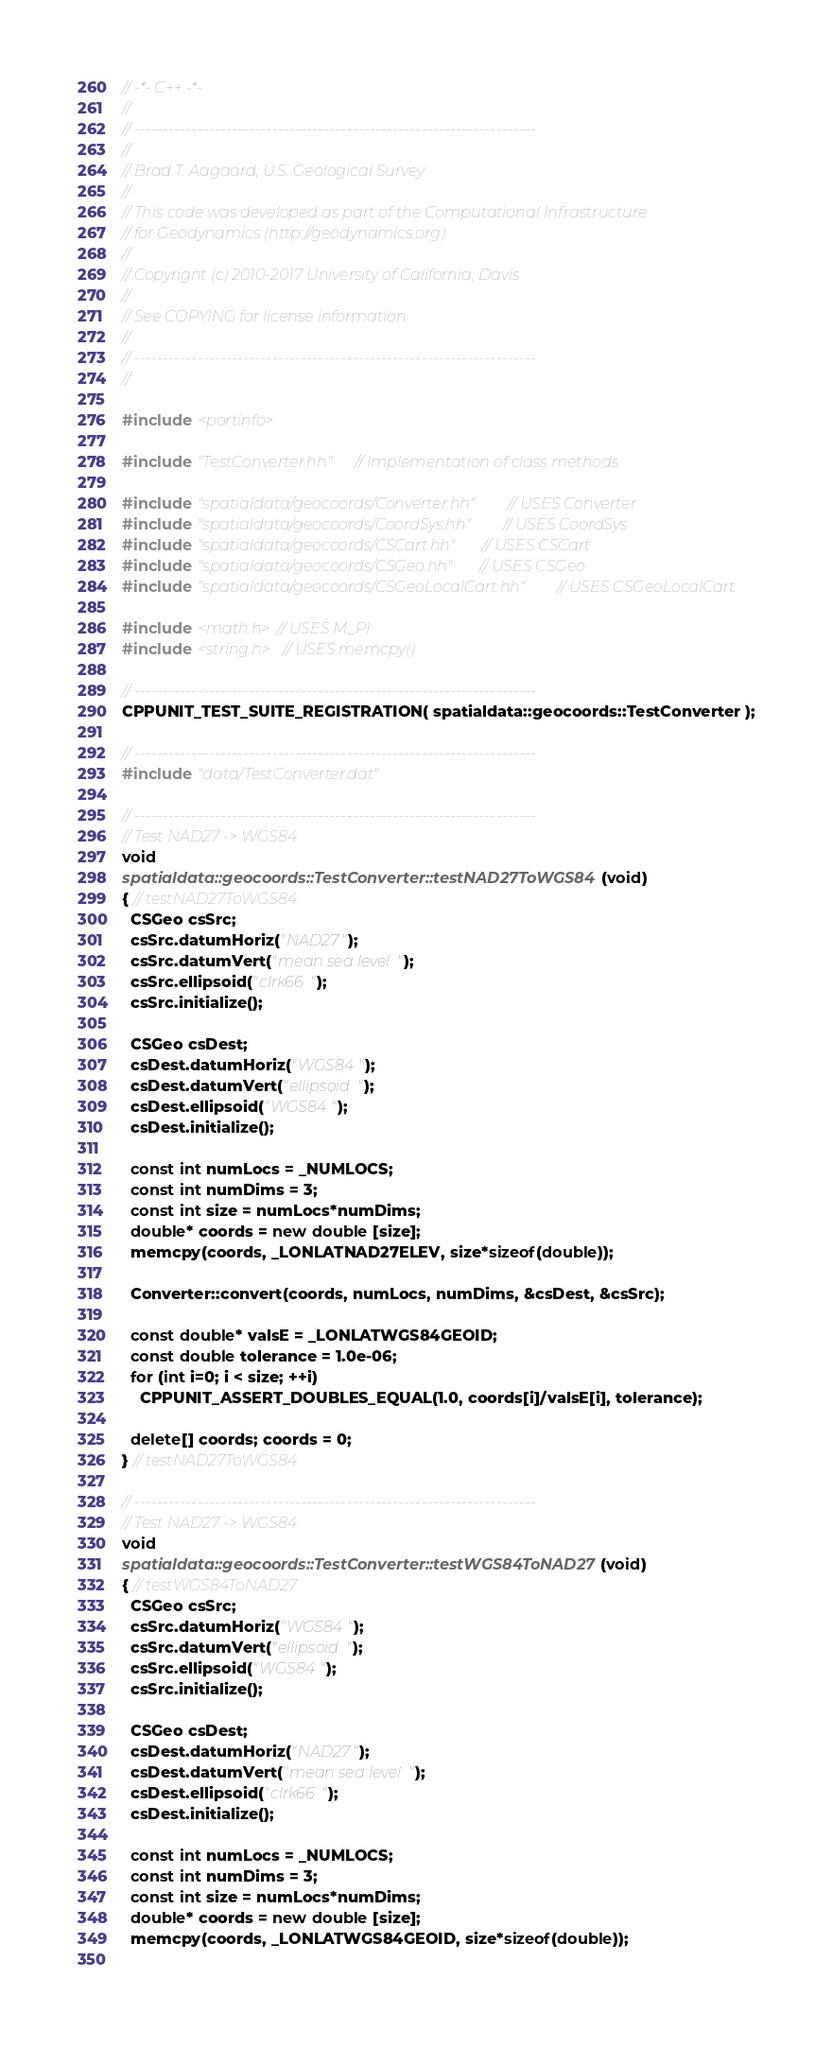Convert code to text. <code><loc_0><loc_0><loc_500><loc_500><_C++_>// -*- C++ -*-
//
// ----------------------------------------------------------------------
//
// Brad T. Aagaard, U.S. Geological Survey
//
// This code was developed as part of the Computational Infrastructure
// for Geodynamics (http://geodynamics.org).
//
// Copyright (c) 2010-2017 University of California, Davis
//
// See COPYING for license information.
//
// ----------------------------------------------------------------------
//

#include <portinfo>

#include "TestConverter.hh" // Implementation of class methods

#include "spatialdata/geocoords/Converter.hh" // USES Converter
#include "spatialdata/geocoords/CoordSys.hh" // USES CoordSys
#include "spatialdata/geocoords/CSCart.hh" // USES CSCart
#include "spatialdata/geocoords/CSGeo.hh" // USES CSGeo
#include "spatialdata/geocoords/CSGeoLocalCart.hh" // USES CSGeoLocalCart

#include <math.h> // USES M_PI
#include <string.h> // USES memcpy()

// ----------------------------------------------------------------------
CPPUNIT_TEST_SUITE_REGISTRATION( spatialdata::geocoords::TestConverter );

// ----------------------------------------------------------------------
#include "data/TestConverter.dat"

// ----------------------------------------------------------------------
// Test NAD27 -> WGS84
void
spatialdata::geocoords::TestConverter::testNAD27ToWGS84(void)
{ // testNAD27ToWGS84
  CSGeo csSrc;
  csSrc.datumHoriz("NAD27");
  csSrc.datumVert("mean sea level");
  csSrc.ellipsoid("clrk66");
  csSrc.initialize();

  CSGeo csDest;
  csDest.datumHoriz("WGS84");
  csDest.datumVert("ellipsoid");
  csDest.ellipsoid("WGS84");
  csDest.initialize();

  const int numLocs = _NUMLOCS;
  const int numDims = 3;
  const int size = numLocs*numDims;
  double* coords = new double [size];
  memcpy(coords, _LONLATNAD27ELEV, size*sizeof(double));
  
  Converter::convert(coords, numLocs, numDims, &csDest, &csSrc);
  
  const double* valsE = _LONLATWGS84GEOID;
  const double tolerance = 1.0e-06;
  for (int i=0; i < size; ++i)
    CPPUNIT_ASSERT_DOUBLES_EQUAL(1.0, coords[i]/valsE[i], tolerance);
  
  delete[] coords; coords = 0;
} // testNAD27ToWGS84

// ----------------------------------------------------------------------
// Test NAD27 -> WGS84
void
spatialdata::geocoords::TestConverter::testWGS84ToNAD27(void)
{ // testWGS84ToNAD27
  CSGeo csSrc;
  csSrc.datumHoriz("WGS84");
  csSrc.datumVert("ellipsoid");
  csSrc.ellipsoid("WGS84");
  csSrc.initialize();

  CSGeo csDest;
  csDest.datumHoriz("NAD27");
  csDest.datumVert("mean sea level");
  csDest.ellipsoid("clrk66");
  csDest.initialize();

  const int numLocs = _NUMLOCS;
  const int numDims = 3;
  const int size = numLocs*numDims;
  double* coords = new double [size];
  memcpy(coords, _LONLATWGS84GEOID, size*sizeof(double));
  </code> 